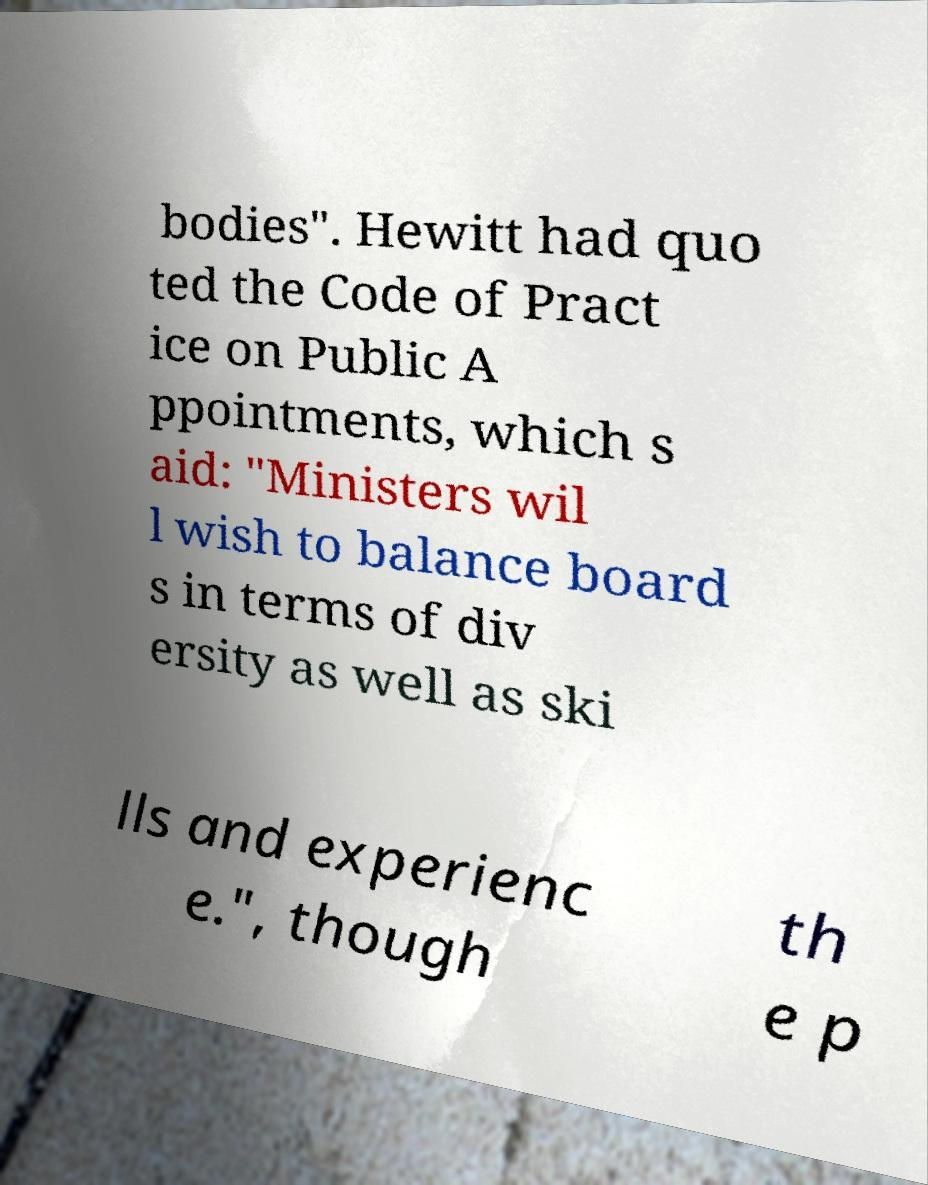What messages or text are displayed in this image? I need them in a readable, typed format. bodies". Hewitt had quo ted the Code of Pract ice on Public A ppointments, which s aid: "Ministers wil l wish to balance board s in terms of div ersity as well as ski lls and experienc e.", though th e p 